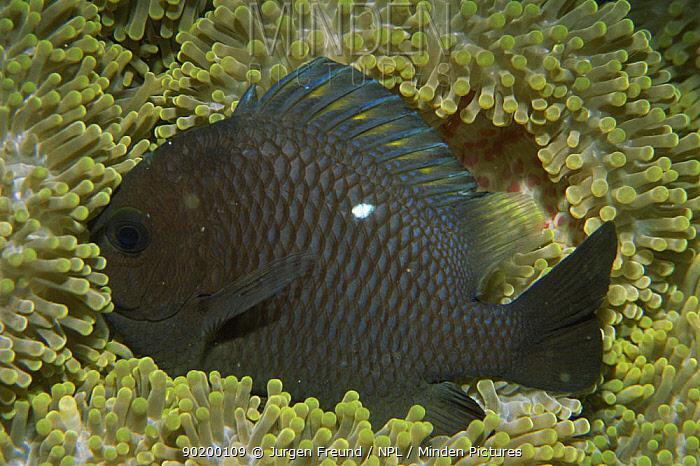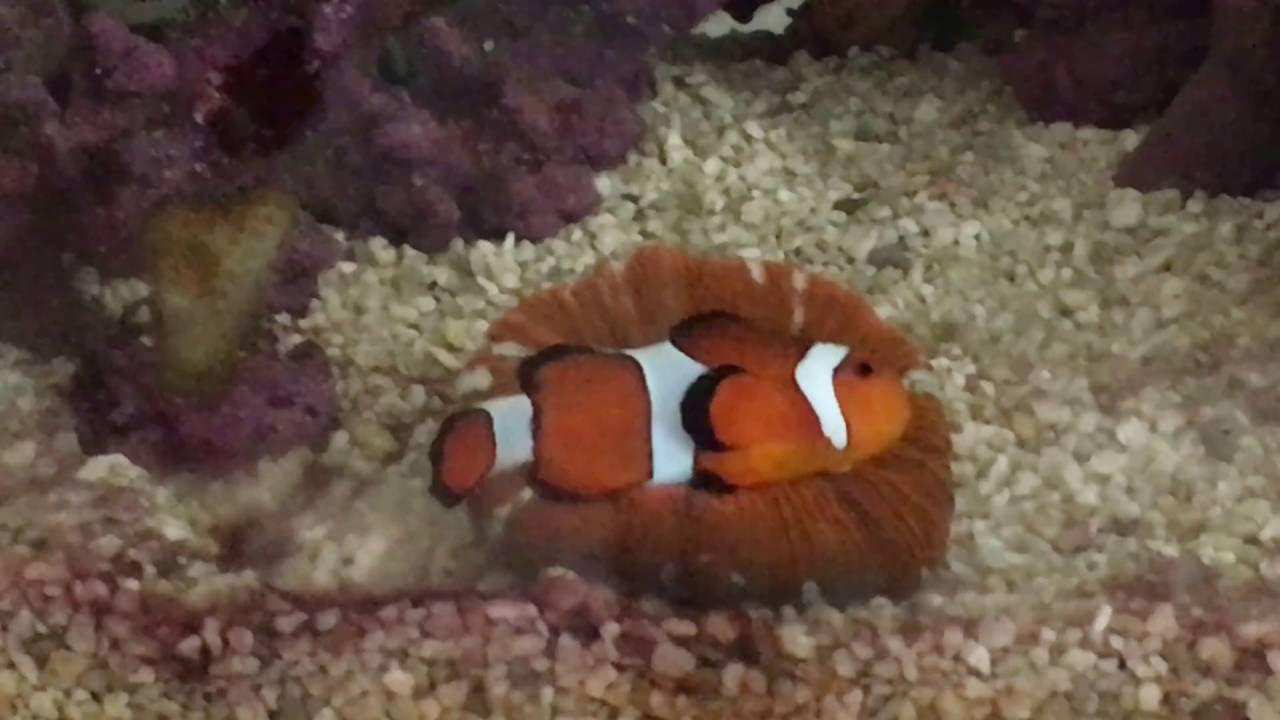The first image is the image on the left, the second image is the image on the right. Given the left and right images, does the statement "In the right image, multiple clown fish with white stripes on bright orange are near flowing anemone tendrils with rounded tips." hold true? Answer yes or no. No. The first image is the image on the left, the second image is the image on the right. Evaluate the accuracy of this statement regarding the images: "The left image contains at least one clown fish with white stripes.". Is it true? Answer yes or no. No. 